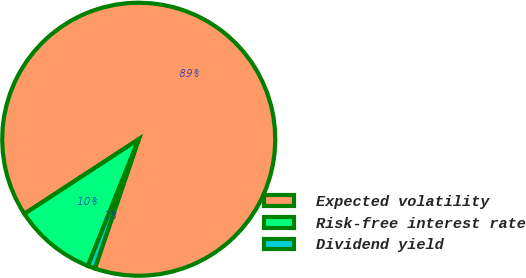<chart> <loc_0><loc_0><loc_500><loc_500><pie_chart><fcel>Expected volatility<fcel>Risk-free interest rate<fcel>Dividend yield<nl><fcel>89.41%<fcel>9.72%<fcel>0.87%<nl></chart> 